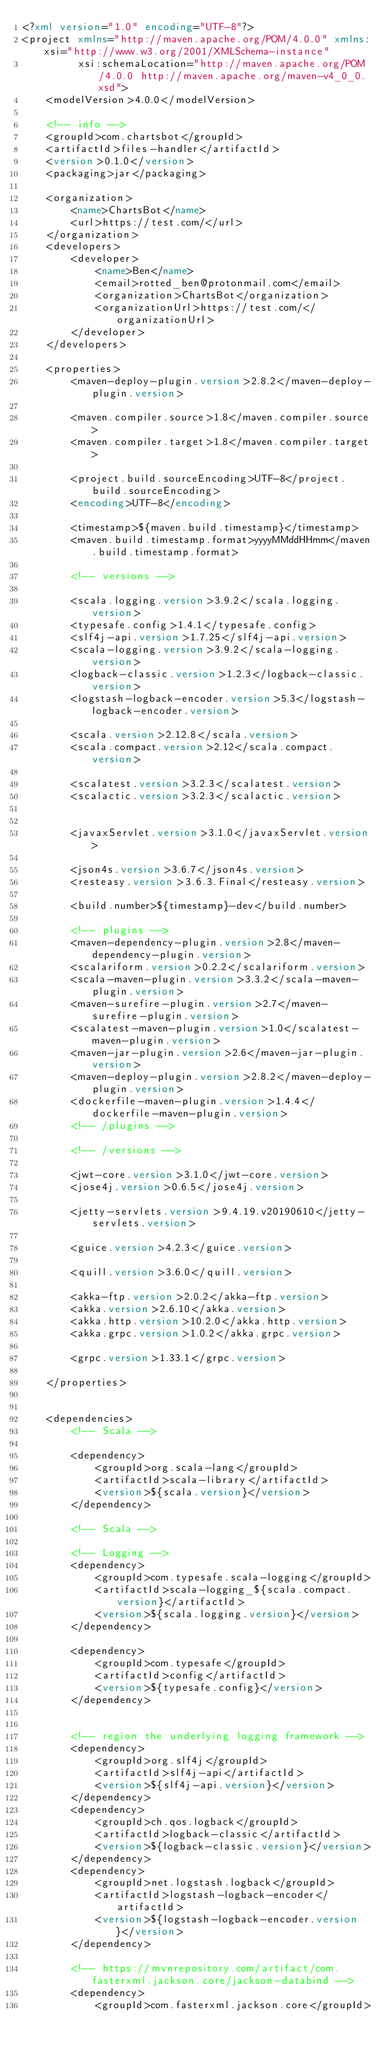Convert code to text. <code><loc_0><loc_0><loc_500><loc_500><_XML_><?xml version="1.0" encoding="UTF-8"?>
<project xmlns="http://maven.apache.org/POM/4.0.0" xmlns:xsi="http://www.w3.org/2001/XMLSchema-instance"
         xsi:schemaLocation="http://maven.apache.org/POM/4.0.0 http://maven.apache.org/maven-v4_0_0.xsd">
    <modelVersion>4.0.0</modelVersion>

    <!-- info -->
    <groupId>com.chartsbot</groupId>
    <artifactId>files-handler</artifactId>
    <version>0.1.0</version>
    <packaging>jar</packaging>

    <organization>
        <name>ChartsBot</name>
        <url>https://test.com/</url>
    </organization>
    <developers>
        <developer>
            <name>Ben</name>
            <email>rotted_ben@protonmail.com</email>
            <organization>ChartsBot</organization>
            <organizationUrl>https://test.com/</organizationUrl>
        </developer>
    </developers>

    <properties>
        <maven-deploy-plugin.version>2.8.2</maven-deploy-plugin.version>

        <maven.compiler.source>1.8</maven.compiler.source>
        <maven.compiler.target>1.8</maven.compiler.target>

        <project.build.sourceEncoding>UTF-8</project.build.sourceEncoding>
        <encoding>UTF-8</encoding>

        <timestamp>${maven.build.timestamp}</timestamp>
        <maven.build.timestamp.format>yyyyMMddHHmm</maven.build.timestamp.format>

        <!-- versions -->

        <scala.logging.version>3.9.2</scala.logging.version>
        <typesafe.config>1.4.1</typesafe.config>
        <slf4j-api.version>1.7.25</slf4j-api.version>
        <scala-logging.version>3.9.2</scala-logging.version>
        <logback-classic.version>1.2.3</logback-classic.version>
        <logstash-logback-encoder.version>5.3</logstash-logback-encoder.version>

        <scala.version>2.12.8</scala.version>
        <scala.compact.version>2.12</scala.compact.version>

        <scalatest.version>3.2.3</scalatest.version>
        <scalactic.version>3.2.3</scalactic.version>


        <javaxServlet.version>3.1.0</javaxServlet.version>

        <json4s.version>3.6.7</json4s.version>
        <resteasy.version>3.6.3.Final</resteasy.version>

        <build.number>${timestamp}-dev</build.number>

        <!-- plugins -->
        <maven-dependency-plugin.version>2.8</maven-dependency-plugin.version>
        <scalariform.version>0.2.2</scalariform.version>
        <scala-maven-plugin.version>3.3.2</scala-maven-plugin.version>
        <maven-surefire-plugin.version>2.7</maven-surefire-plugin.version>
        <scalatest-maven-plugin.version>1.0</scalatest-maven-plugin.version>
        <maven-jar-plugin.version>2.6</maven-jar-plugin.version>
        <maven-deploy-plugin.version>2.8.2</maven-deploy-plugin.version>
        <dockerfile-maven-plugin.version>1.4.4</dockerfile-maven-plugin.version>
        <!-- /plugins -->

        <!-- /versions -->

        <jwt-core.version>3.1.0</jwt-core.version>
        <jose4j.version>0.6.5</jose4j.version>

        <jetty-servlets.version>9.4.19.v20190610</jetty-servlets.version>

        <guice.version>4.2.3</guice.version>

        <quill.version>3.6.0</quill.version>

        <akka-ftp.version>2.0.2</akka-ftp.version>
        <akka.version>2.6.10</akka.version>
        <akka.http.version>10.2.0</akka.http.version>
        <akka.grpc.version>1.0.2</akka.grpc.version>

        <grpc.version>1.33.1</grpc.version>

    </properties>


    <dependencies>
        <!-- Scala -->

        <dependency>
            <groupId>org.scala-lang</groupId>
            <artifactId>scala-library</artifactId>
            <version>${scala.version}</version>
        </dependency>

        <!-- Scala -->

        <!-- Logging -->
        <dependency>
            <groupId>com.typesafe.scala-logging</groupId>
            <artifactId>scala-logging_${scala.compact.version}</artifactId>
            <version>${scala.logging.version}</version>
        </dependency>

        <dependency>
            <groupId>com.typesafe</groupId>
            <artifactId>config</artifactId>
            <version>${typesafe.config}</version>
        </dependency>


        <!-- region the underlying logging framework -->
        <dependency>
            <groupId>org.slf4j</groupId>
            <artifactId>slf4j-api</artifactId>
            <version>${slf4j-api.version}</version>
        </dependency>
        <dependency>
            <groupId>ch.qos.logback</groupId>
            <artifactId>logback-classic</artifactId>
            <version>${logback-classic.version}</version>
        </dependency>
        <dependency>
            <groupId>net.logstash.logback</groupId>
            <artifactId>logstash-logback-encoder</artifactId>
            <version>${logstash-logback-encoder.version}</version>
        </dependency>

        <!-- https://mvnrepository.com/artifact/com.fasterxml.jackson.core/jackson-databind -->
        <dependency>
            <groupId>com.fasterxml.jackson.core</groupId></code> 